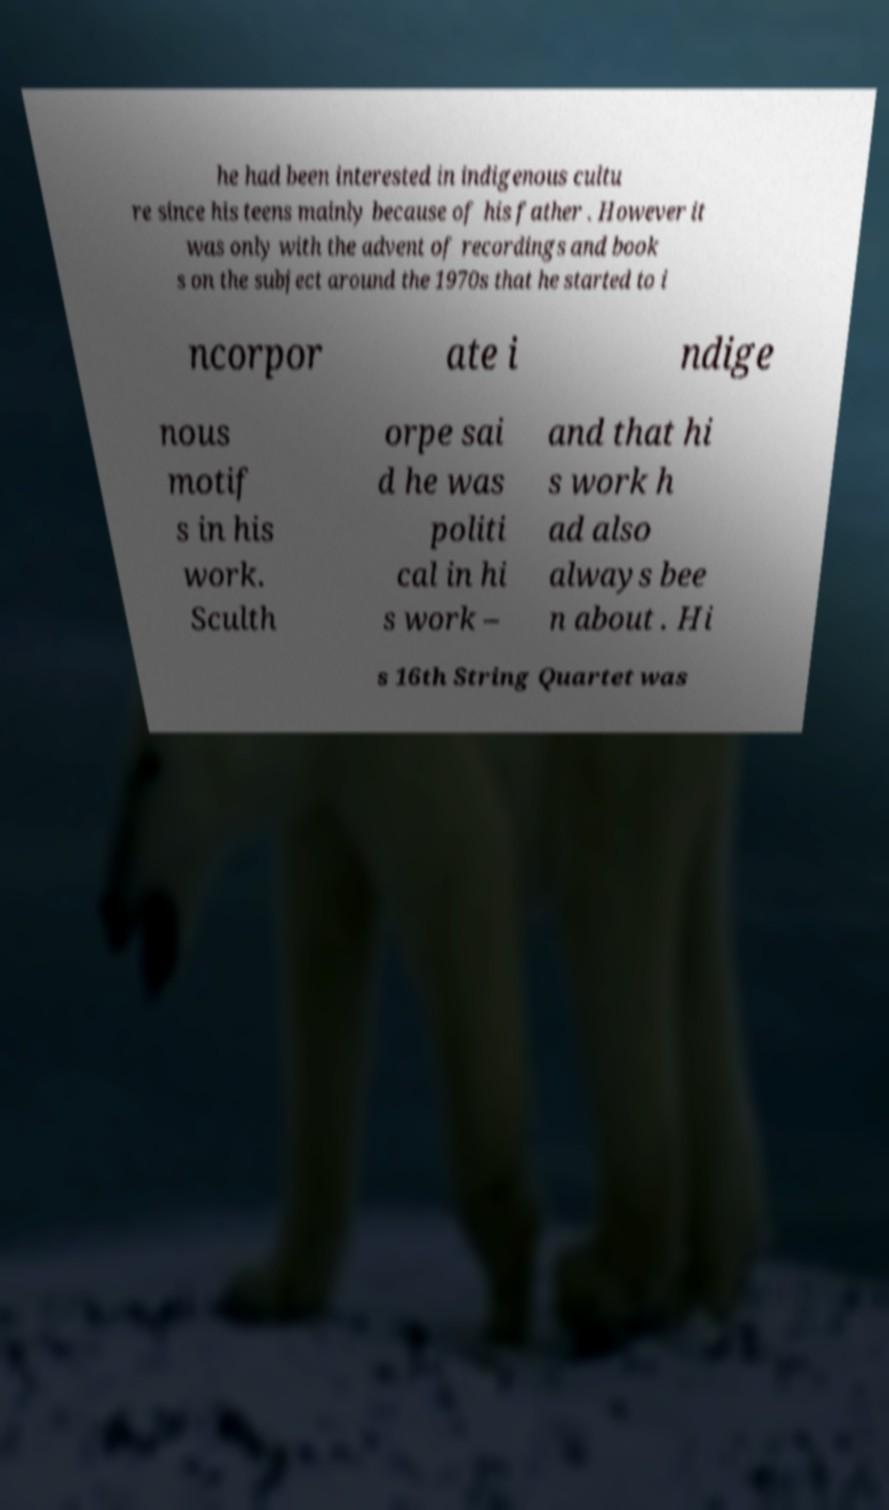Can you read and provide the text displayed in the image?This photo seems to have some interesting text. Can you extract and type it out for me? he had been interested in indigenous cultu re since his teens mainly because of his father . However it was only with the advent of recordings and book s on the subject around the 1970s that he started to i ncorpor ate i ndige nous motif s in his work. Sculth orpe sai d he was politi cal in hi s work – and that hi s work h ad also always bee n about . Hi s 16th String Quartet was 